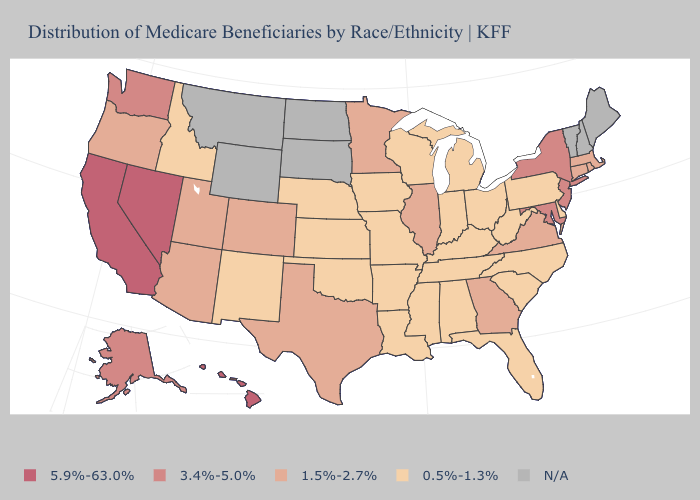Does the first symbol in the legend represent the smallest category?
Write a very short answer. No. Does the map have missing data?
Short answer required. Yes. What is the highest value in states that border Ohio?
Quick response, please. 0.5%-1.3%. Which states have the lowest value in the USA?
Be succinct. Alabama, Arkansas, Delaware, Florida, Idaho, Indiana, Iowa, Kansas, Kentucky, Louisiana, Michigan, Mississippi, Missouri, Nebraska, New Mexico, North Carolina, Ohio, Oklahoma, Pennsylvania, South Carolina, Tennessee, West Virginia, Wisconsin. Name the states that have a value in the range 1.5%-2.7%?
Write a very short answer. Arizona, Colorado, Connecticut, Georgia, Illinois, Massachusetts, Minnesota, Oregon, Rhode Island, Texas, Utah, Virginia. What is the highest value in the Northeast ?
Concise answer only. 3.4%-5.0%. Name the states that have a value in the range 5.9%-63.0%?
Give a very brief answer. California, Hawaii, Nevada. Does New Mexico have the lowest value in the USA?
Concise answer only. Yes. What is the highest value in the West ?
Be succinct. 5.9%-63.0%. What is the highest value in states that border Virginia?
Short answer required. 3.4%-5.0%. What is the highest value in the USA?
Quick response, please. 5.9%-63.0%. What is the lowest value in the Northeast?
Short answer required. 0.5%-1.3%. Among the states that border Georgia , which have the highest value?
Give a very brief answer. Alabama, Florida, North Carolina, South Carolina, Tennessee. What is the lowest value in the MidWest?
Short answer required. 0.5%-1.3%. What is the value of Rhode Island?
Short answer required. 1.5%-2.7%. 